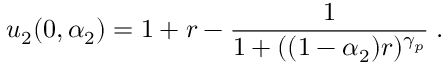<formula> <loc_0><loc_0><loc_500><loc_500>u _ { 2 } ( 0 , \alpha _ { 2 } ) = 1 + r - \frac { 1 } { 1 + ( ( 1 - \alpha _ { 2 } ) r ) ^ { \gamma _ { p } } } \, .</formula> 